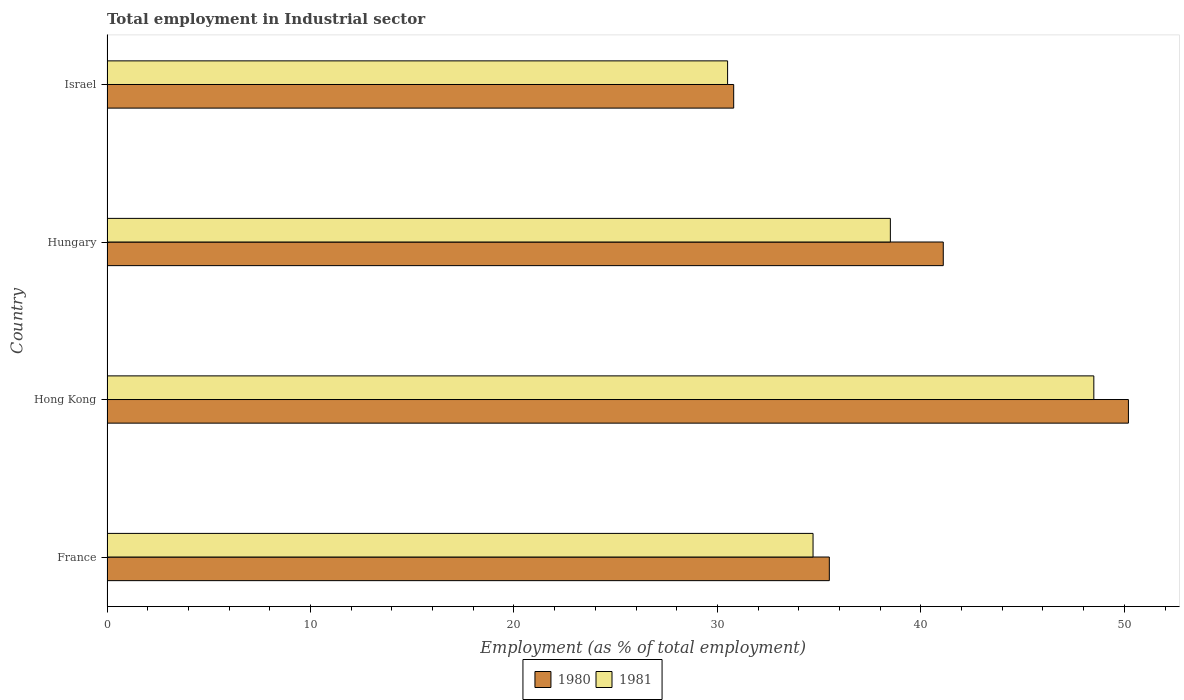What is the label of the 3rd group of bars from the top?
Keep it short and to the point. Hong Kong. What is the employment in industrial sector in 1981 in Israel?
Offer a terse response. 30.5. Across all countries, what is the maximum employment in industrial sector in 1981?
Your answer should be very brief. 48.5. Across all countries, what is the minimum employment in industrial sector in 1981?
Your answer should be very brief. 30.5. In which country was the employment in industrial sector in 1980 maximum?
Give a very brief answer. Hong Kong. In which country was the employment in industrial sector in 1980 minimum?
Offer a terse response. Israel. What is the total employment in industrial sector in 1980 in the graph?
Keep it short and to the point. 157.6. What is the difference between the employment in industrial sector in 1980 in Hong Kong and that in Israel?
Provide a succinct answer. 19.4. What is the difference between the employment in industrial sector in 1981 in France and the employment in industrial sector in 1980 in Hungary?
Keep it short and to the point. -6.4. What is the average employment in industrial sector in 1980 per country?
Your answer should be compact. 39.4. What is the difference between the employment in industrial sector in 1980 and employment in industrial sector in 1981 in France?
Your answer should be compact. 0.8. What is the ratio of the employment in industrial sector in 1981 in France to that in Hong Kong?
Your answer should be very brief. 0.72. What is the difference between the highest and the lowest employment in industrial sector in 1980?
Give a very brief answer. 19.4. In how many countries, is the employment in industrial sector in 1981 greater than the average employment in industrial sector in 1981 taken over all countries?
Keep it short and to the point. 2. Is the sum of the employment in industrial sector in 1980 in France and Hungary greater than the maximum employment in industrial sector in 1981 across all countries?
Keep it short and to the point. Yes. How many countries are there in the graph?
Provide a short and direct response. 4. What is the difference between two consecutive major ticks on the X-axis?
Offer a terse response. 10. Does the graph contain grids?
Ensure brevity in your answer.  No. What is the title of the graph?
Offer a terse response. Total employment in Industrial sector. Does "1977" appear as one of the legend labels in the graph?
Ensure brevity in your answer.  No. What is the label or title of the X-axis?
Offer a very short reply. Employment (as % of total employment). What is the Employment (as % of total employment) in 1980 in France?
Your answer should be compact. 35.5. What is the Employment (as % of total employment) in 1981 in France?
Make the answer very short. 34.7. What is the Employment (as % of total employment) in 1980 in Hong Kong?
Offer a very short reply. 50.2. What is the Employment (as % of total employment) in 1981 in Hong Kong?
Provide a short and direct response. 48.5. What is the Employment (as % of total employment) in 1980 in Hungary?
Offer a terse response. 41.1. What is the Employment (as % of total employment) in 1981 in Hungary?
Your answer should be very brief. 38.5. What is the Employment (as % of total employment) of 1980 in Israel?
Provide a short and direct response. 30.8. What is the Employment (as % of total employment) in 1981 in Israel?
Keep it short and to the point. 30.5. Across all countries, what is the maximum Employment (as % of total employment) in 1980?
Provide a succinct answer. 50.2. Across all countries, what is the maximum Employment (as % of total employment) in 1981?
Make the answer very short. 48.5. Across all countries, what is the minimum Employment (as % of total employment) of 1980?
Make the answer very short. 30.8. Across all countries, what is the minimum Employment (as % of total employment) of 1981?
Keep it short and to the point. 30.5. What is the total Employment (as % of total employment) in 1980 in the graph?
Your answer should be compact. 157.6. What is the total Employment (as % of total employment) of 1981 in the graph?
Offer a terse response. 152.2. What is the difference between the Employment (as % of total employment) of 1980 in France and that in Hong Kong?
Offer a very short reply. -14.7. What is the difference between the Employment (as % of total employment) of 1981 in France and that in Hong Kong?
Keep it short and to the point. -13.8. What is the difference between the Employment (as % of total employment) of 1980 in Hong Kong and that in Israel?
Provide a succinct answer. 19.4. What is the difference between the Employment (as % of total employment) in 1980 in France and the Employment (as % of total employment) in 1981 in Hong Kong?
Your answer should be very brief. -13. What is the difference between the Employment (as % of total employment) in 1980 in Hong Kong and the Employment (as % of total employment) in 1981 in Israel?
Your answer should be compact. 19.7. What is the average Employment (as % of total employment) of 1980 per country?
Ensure brevity in your answer.  39.4. What is the average Employment (as % of total employment) of 1981 per country?
Your answer should be very brief. 38.05. What is the difference between the Employment (as % of total employment) of 1980 and Employment (as % of total employment) of 1981 in Hong Kong?
Your response must be concise. 1.7. What is the difference between the Employment (as % of total employment) of 1980 and Employment (as % of total employment) of 1981 in Hungary?
Your answer should be compact. 2.6. What is the difference between the Employment (as % of total employment) of 1980 and Employment (as % of total employment) of 1981 in Israel?
Your answer should be very brief. 0.3. What is the ratio of the Employment (as % of total employment) of 1980 in France to that in Hong Kong?
Offer a terse response. 0.71. What is the ratio of the Employment (as % of total employment) in 1981 in France to that in Hong Kong?
Your answer should be compact. 0.72. What is the ratio of the Employment (as % of total employment) in 1980 in France to that in Hungary?
Your answer should be compact. 0.86. What is the ratio of the Employment (as % of total employment) of 1981 in France to that in Hungary?
Your answer should be compact. 0.9. What is the ratio of the Employment (as % of total employment) of 1980 in France to that in Israel?
Offer a very short reply. 1.15. What is the ratio of the Employment (as % of total employment) in 1981 in France to that in Israel?
Offer a terse response. 1.14. What is the ratio of the Employment (as % of total employment) in 1980 in Hong Kong to that in Hungary?
Give a very brief answer. 1.22. What is the ratio of the Employment (as % of total employment) of 1981 in Hong Kong to that in Hungary?
Ensure brevity in your answer.  1.26. What is the ratio of the Employment (as % of total employment) of 1980 in Hong Kong to that in Israel?
Give a very brief answer. 1.63. What is the ratio of the Employment (as % of total employment) in 1981 in Hong Kong to that in Israel?
Keep it short and to the point. 1.59. What is the ratio of the Employment (as % of total employment) in 1980 in Hungary to that in Israel?
Provide a succinct answer. 1.33. What is the ratio of the Employment (as % of total employment) of 1981 in Hungary to that in Israel?
Offer a very short reply. 1.26. What is the difference between the highest and the second highest Employment (as % of total employment) of 1980?
Provide a succinct answer. 9.1. What is the difference between the highest and the second highest Employment (as % of total employment) of 1981?
Keep it short and to the point. 10. 